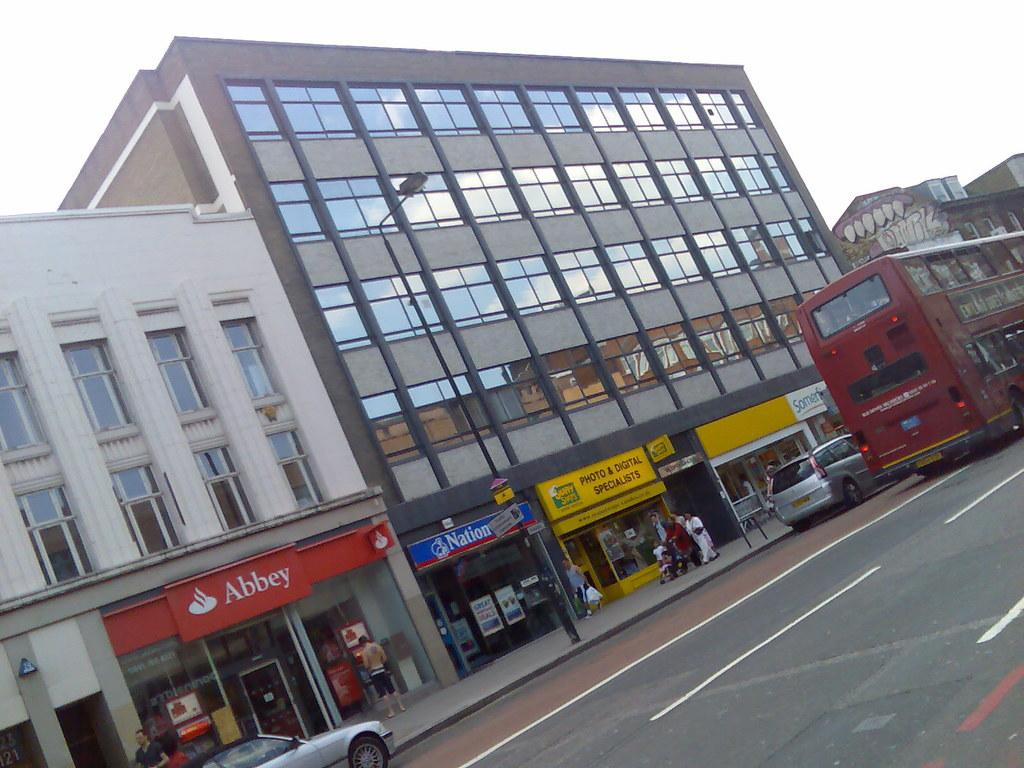What can be seen on the road in the image? There are vehicles on the road in the image. What can be seen on the pavement in the image? There are people on the pavement in the image. What type of structures are visible in the image? There are buildings visible in the image. What is attached to the light pole in the image? There is a board attached to the light pole in the image. What is visible in the background of the image? The sky is visible in the background of the image. Can you see a swing in the image? There is no swing present in the image. How many fingers are visible on the people in the image? The number of fingers visible on the people in the image cannot be determined from the image alone. 